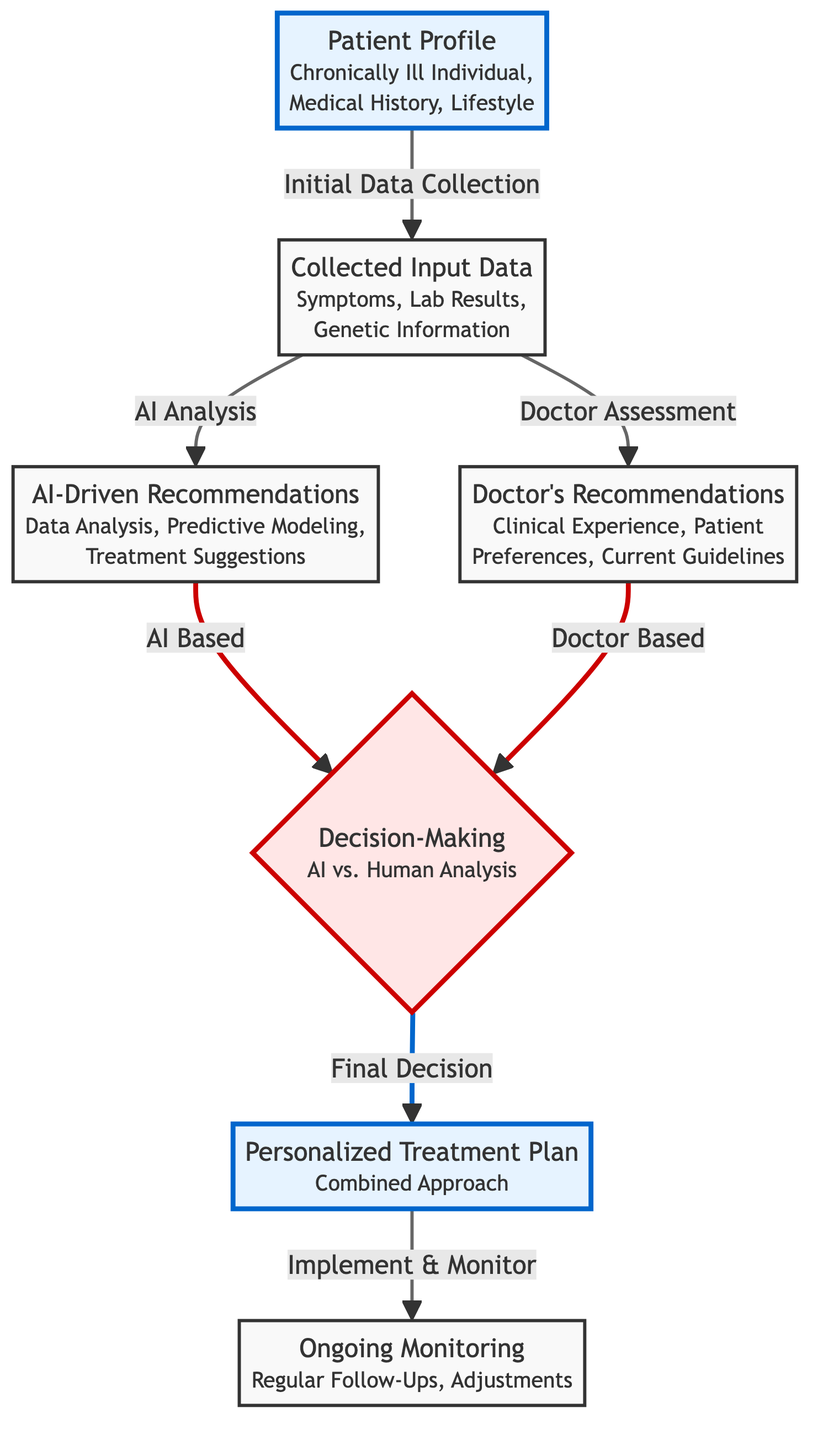What type of individual is depicted in the patient profile? The patient profile node specifies "Chronically Ill Individual," which informs us of the type of individual being represented.
Answer: Chronically Ill Individual What are the two sources of recommendations in the diagram? In the diagram, the two sources of recommendations are clearly labeled as "AI-Driven Recommendations" and "Doctor's Recommendations."
Answer: AI-Driven Recommendations and Doctor's Recommendations How is the decision-making process illustrated in the diagram? The diagram presents a decision-making node titled "Decision-Making" which evaluates options for AI vs. Human Analysis, leading to the next step of creating a treatment plan.
Answer: AI vs. Human Analysis Which component emphasizes ongoing patient care? The node labeled "Ongoing Monitoring" outlines the patient care process, describing regular follow-ups and adjustments, emphasizing its importance.
Answer: Ongoing Monitoring What is the output of the decision-making process? Following the decision-making process, the output node reflects the "Personalized Treatment Plan" that combines both AI and human insights, indicating the final decision's result.
Answer: Personalized Treatment Plan What is the relationship between input data and recommendations? The diagram shows that input data is processed separately by both "AI-Driven Recommendations" and "Doctor's Recommendations," indicating two distinct paths of assessment based on the same input data.
Answer: AI Analysis and Doctor Assessment How many nodes represent different components of the treatment process? The diagram illustrates a total of five distinct nodes representing various components of the treatment process: Patient Profile, Input Data, AI Recommendations, Human Recommendations, and Personalized Treatment Plan.
Answer: Five Which step signifies the preparation for treatment implementation? The link labeled "Implement & Monitor" following the "Personalized Treatment Plan" node represents the step that prepares for implementing the treatment plan.
Answer: Implement & Monitor 